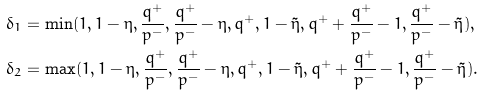Convert formula to latex. <formula><loc_0><loc_0><loc_500><loc_500>\delta _ { 1 } = & \, \min ( 1 , 1 - \eta , \frac { q ^ { + } } { p ^ { - } } , \frac { q ^ { + } } { p ^ { - } } - \eta , q ^ { + } , 1 - \tilde { \eta } , q ^ { + } + \frac { q ^ { + } } { p ^ { - } } - 1 , \frac { q ^ { + } } { p ^ { - } } - \tilde { \eta } ) , \\ \delta _ { 2 } = & \, \max ( 1 , 1 - \eta , \frac { q ^ { + } } { p ^ { - } } , \frac { q ^ { + } } { p ^ { - } } - \eta , q ^ { + } , 1 - \tilde { \eta } , q ^ { + } + \frac { q ^ { + } } { p ^ { - } } - 1 , \frac { q ^ { + } } { p ^ { - } } - \tilde { \eta } ) .</formula> 